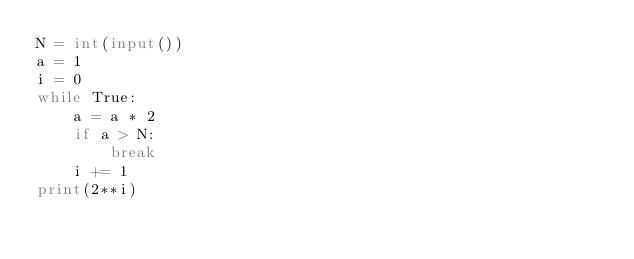<code> <loc_0><loc_0><loc_500><loc_500><_Python_>N = int(input())
a = 1
i = 0
while True:
    a = a * 2
    if a > N:
        break
    i += 1
print(2**i)</code> 